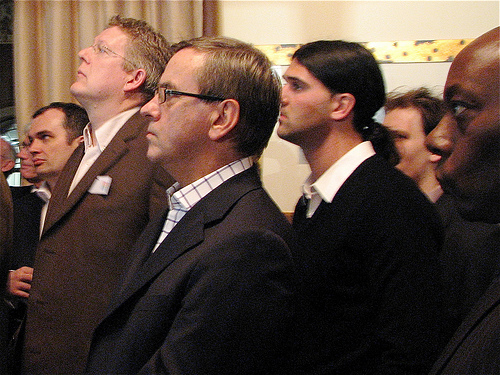<image>
Is the glasses to the right of the window? No. The glasses is not to the right of the window. The horizontal positioning shows a different relationship. 